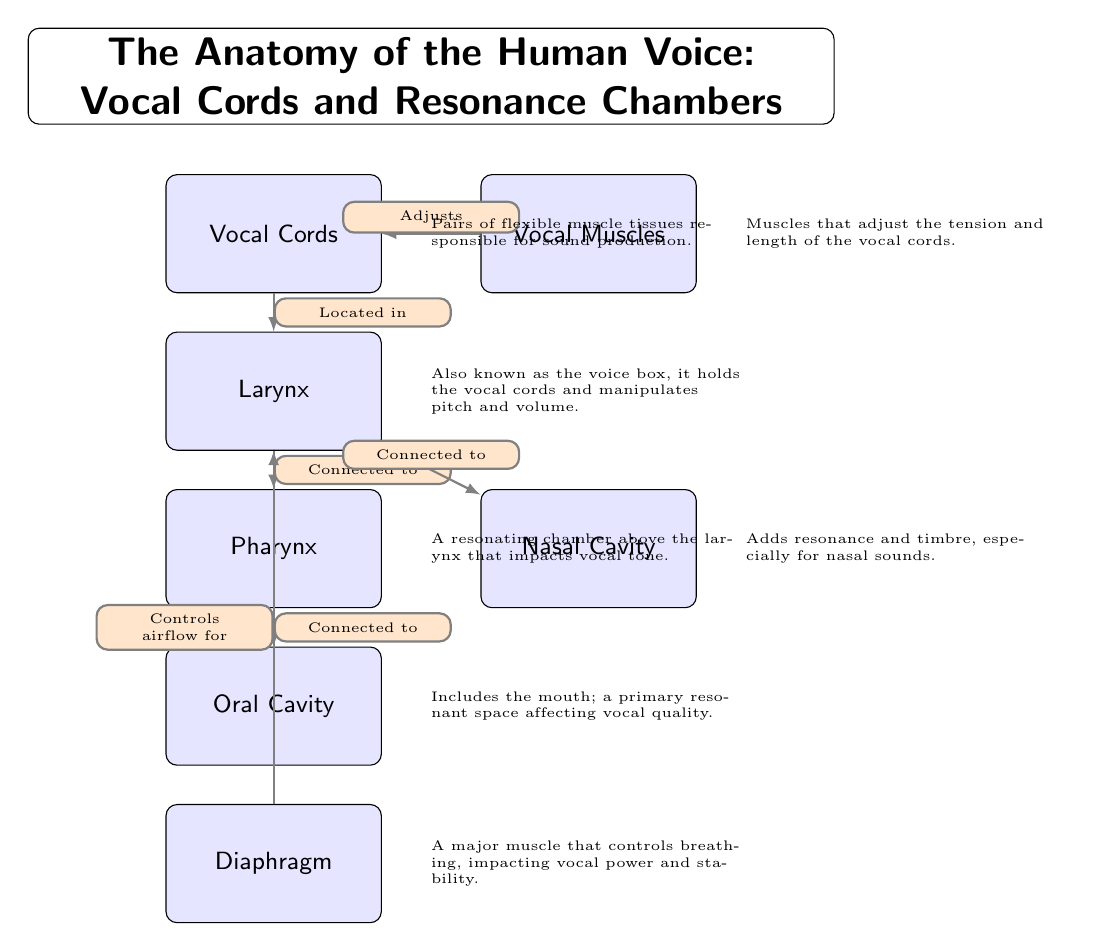What are the two primary components responsible for sound production? The diagram identifies the "Vocal Cords" as the primary component responsible for sound production and the "Vocal Muscles" for adjusting the tension and length of the vocal cords to facilitate this process.
Answer: Vocal Cords, Vocal Muscles What chamber is located immediately below the vocal cords? According to the diagram, the "Larynx" is positioned directly beneath the "Vocal Cords," indicating it is the immediate chamber following them.
Answer: Larynx Which two structures are labeled as resonating chambers? The diagram lists the "Pharynx" and the "Oral Cavity" as two chambers that largely contribute to the resonance of the voice, affecting vocal quality and tone.
Answer: Pharynx, Oral Cavity How many connections are shown in the diagram? The diagram displays a total of six directed edges indicating connections among the nodes, illustrating the relationships among the different elements of the human voice anatomy.
Answer: 6 What role does the diaphragm play in the vocal process according to the diagram? The "Diaphragm" is indicated in the diagram as something that controls airflow necessary for voice production, signifying its role in breathing while singing.
Answer: Controls airflow for What structure is shown to adjust the tension of vocal cords? The diagram clearly indicates that the "Vocal Muscles" are responsible for adjusting the tension and length of the vocal cords, which directly impacts sound production.
Answer: Vocal Muscles Which chamber is connected to both the larynx and nasal cavity? The "Pharynx" is identified in the diagram as a chamber that is connected to both the "Larynx" below and the "Nasal Cavity" to the side, facilitating a shared role in vocalization.
Answer: Pharynx What function does the oral cavity have in voice production? The diagram notes that the "Oral Cavity" serves as a primary resonant space impacting vocal quality, affecting the characteristics of sound produced when singing.
Answer: A primary resonant space affecting vocal quality Which structure is referred to as the voice box? As per the diagram, the "Larynx" is labeled as the voice box, indicating its function and significance in the anatomy of the human voice.
Answer: Larynx 